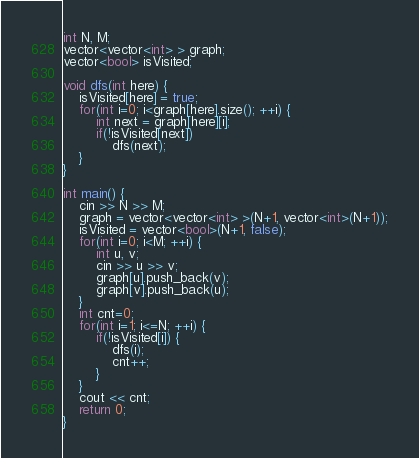<code> <loc_0><loc_0><loc_500><loc_500><_C++_>
int N, M;
vector<vector<int> > graph;
vector<bool> isVisited;

void dfs(int here) {
	isVisited[here] = true;	
	for(int i=0; i<graph[here].size(); ++i) {
		int next = graph[here][i];
		if(!isVisited[next])
			dfs(next);
	}
}

int main() {
	cin >> N >> M;
	graph = vector<vector<int> >(N+1, vector<int>(N+1));
	isVisited = vector<bool>(N+1, false);
	for(int i=0; i<M; ++i) {
		int u, v;
		cin >> u >> v;
		graph[u].push_back(v);
		graph[v].push_back(u);
	}
	int cnt=0;
	for(int i=1; i<=N; ++i) {
		if(!isVisited[i]) {
			dfs(i);
			cnt++;
		}
	}
	cout << cnt;
	return 0;	
}
</code> 